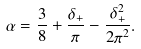Convert formula to latex. <formula><loc_0><loc_0><loc_500><loc_500>\alpha = \frac { 3 } { 8 } + \frac { \delta _ { + } } { \pi } - \frac { \delta _ { + } ^ { 2 } } { 2 \pi ^ { 2 } } .</formula> 